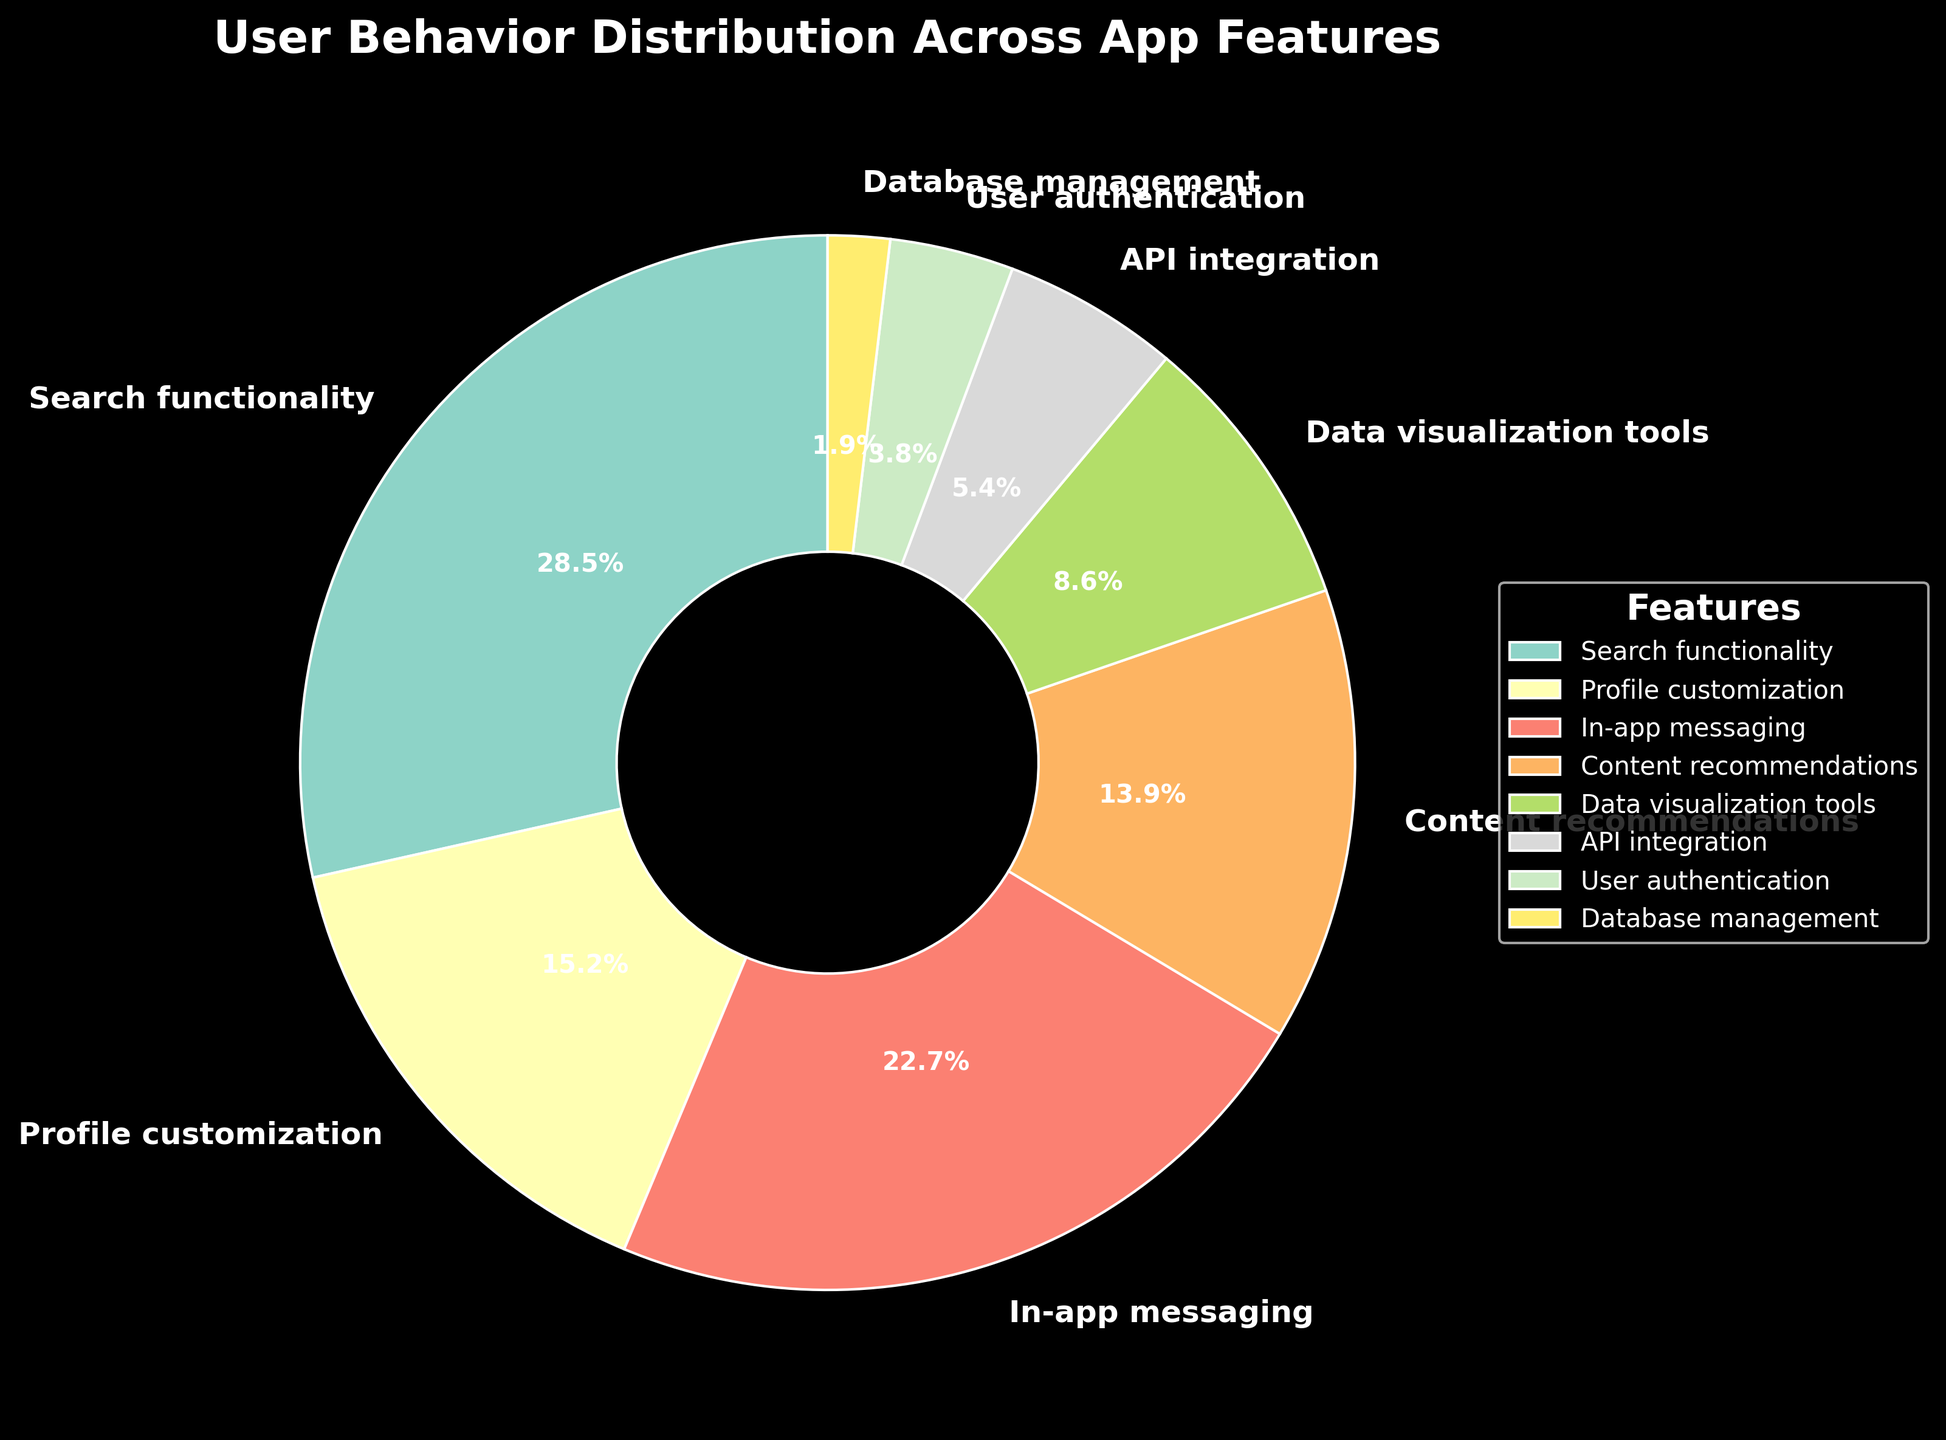What feature has the highest usage percentage? From the pie chart, the size of each wedge is proportional to the usage percentage. The largest wedge represents the feature with the highest usage percentage. The "Search functionality" wedge is visibly the largest.
Answer: Search functionality Which feature has the lowest usage percentage? The smallest wedge in the pie chart represents the feature with the lowest usage percentage. The "Database management" feature is the smallest wedge.
Answer: Database management What is the combined usage percentage of "Search functionality" and "In-app messaging"? The usage percentages for these features are 28.5% (Search functionality) and 22.7% (In-app messaging). Adding these values gives: 28.5 + 22.7 = 51.2.
Answer: 51.2% Which feature has a larger usage percentage: "Profile customization" or "Content recommendations"? Comparing the two wedges, "Profile customization" has a usage percentage of 15.2% while "Content recommendations" has 13.9%.
Answer: Profile customization Is the usage percentage of "Data visualization tools" greater than that of "API integration"? Comparing the wedges' sizes, "Data visualization tools" has a usage percentage of 8.6%, which is greater than "API integration" at 5.4%.
Answer: Yes What is the usage percentage difference between "Profile customization" and "User authentication"? The usage percentages are 15.2% (Profile customization) and 3.8% (User authentication). The difference is calculated as 15.2 - 3.8 = 11.4.
Answer: 11.4% How does the usage percentage of "Content recommendations" compare to the sum of "Database management" and "User authentication"? The usage percentage of "Content recommendations" is 13.9%. The sum of "Database management" and "User authentication" percentages is 1.9 + 3.8 = 5.7. 13.9% is greater than 5.7%.
Answer: Greater Which feature makes up nearly a quarter of the total usage percentage? "In-app messaging" has a usage percentage of 22.7%, which is close to 25% or a quarter of the total. This is the closest value to 25% compared to other features.
Answer: In-app messaging What is the visual representation (color) of the feature with the second lowest usage percentage? The feature "User authentication" has the second lowest usage percentage at 3.8%. According to the color scheme used in the chart, this feature is visually represented by a specific color (e.g., blue, yellow).
Answer: (Specify color from the plotted chart based on provided color scheme, e.g., Blue) Is there any feature with a usage percentage below 5%? If so, which one(s)? Features with percentage wedges less than 5% are visible on the pie chart. "API integration" (5.4%), "User authentication" (3.8%), and "Database management" (1.9%) are observed for their respective sizes. Thus, "User authentication" and "Database management" are below 5%.
Answer: User authentication, Database management 